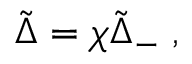Convert formula to latex. <formula><loc_0><loc_0><loc_500><loc_500>\tilde { \Delta } = \chi { \tilde { \Delta } } _ { - } \, ,</formula> 